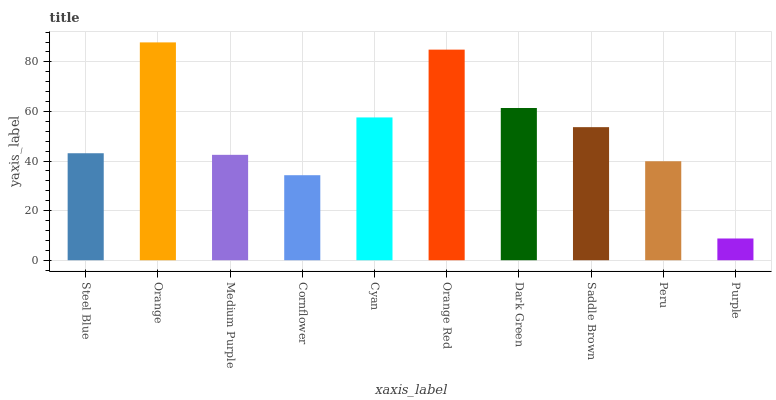Is Purple the minimum?
Answer yes or no. Yes. Is Orange the maximum?
Answer yes or no. Yes. Is Medium Purple the minimum?
Answer yes or no. No. Is Medium Purple the maximum?
Answer yes or no. No. Is Orange greater than Medium Purple?
Answer yes or no. Yes. Is Medium Purple less than Orange?
Answer yes or no. Yes. Is Medium Purple greater than Orange?
Answer yes or no. No. Is Orange less than Medium Purple?
Answer yes or no. No. Is Saddle Brown the high median?
Answer yes or no. Yes. Is Steel Blue the low median?
Answer yes or no. Yes. Is Purple the high median?
Answer yes or no. No. Is Peru the low median?
Answer yes or no. No. 